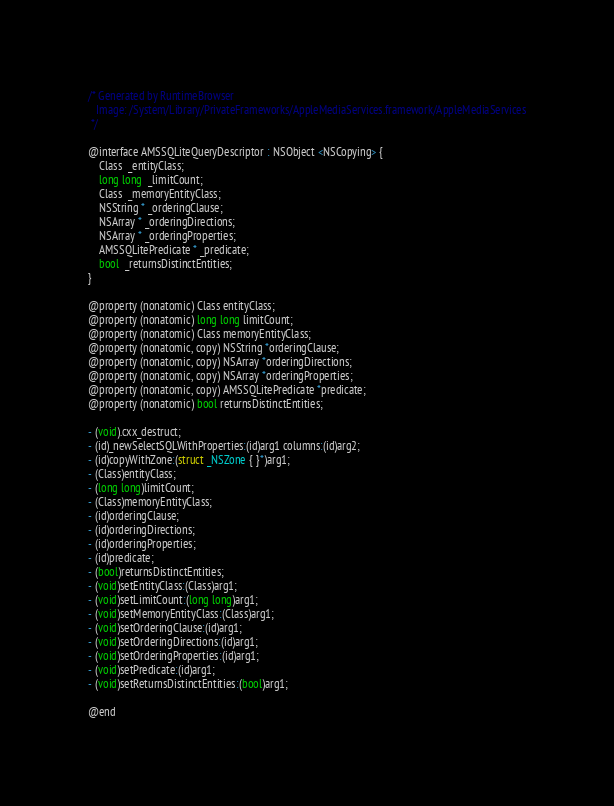<code> <loc_0><loc_0><loc_500><loc_500><_C_>/* Generated by RuntimeBrowser
   Image: /System/Library/PrivateFrameworks/AppleMediaServices.framework/AppleMediaServices
 */

@interface AMSSQLiteQueryDescriptor : NSObject <NSCopying> {
    Class  _entityClass;
    long long  _limitCount;
    Class  _memoryEntityClass;
    NSString * _orderingClause;
    NSArray * _orderingDirections;
    NSArray * _orderingProperties;
    AMSSQLitePredicate * _predicate;
    bool  _returnsDistinctEntities;
}

@property (nonatomic) Class entityClass;
@property (nonatomic) long long limitCount;
@property (nonatomic) Class memoryEntityClass;
@property (nonatomic, copy) NSString *orderingClause;
@property (nonatomic, copy) NSArray *orderingDirections;
@property (nonatomic, copy) NSArray *orderingProperties;
@property (nonatomic, copy) AMSSQLitePredicate *predicate;
@property (nonatomic) bool returnsDistinctEntities;

- (void).cxx_destruct;
- (id)_newSelectSQLWithProperties:(id)arg1 columns:(id)arg2;
- (id)copyWithZone:(struct _NSZone { }*)arg1;
- (Class)entityClass;
- (long long)limitCount;
- (Class)memoryEntityClass;
- (id)orderingClause;
- (id)orderingDirections;
- (id)orderingProperties;
- (id)predicate;
- (bool)returnsDistinctEntities;
- (void)setEntityClass:(Class)arg1;
- (void)setLimitCount:(long long)arg1;
- (void)setMemoryEntityClass:(Class)arg1;
- (void)setOrderingClause:(id)arg1;
- (void)setOrderingDirections:(id)arg1;
- (void)setOrderingProperties:(id)arg1;
- (void)setPredicate:(id)arg1;
- (void)setReturnsDistinctEntities:(bool)arg1;

@end
</code> 